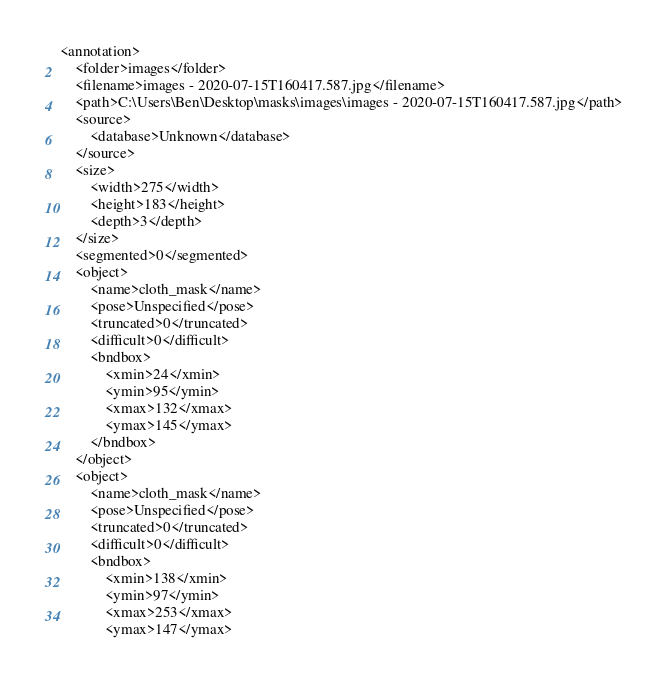<code> <loc_0><loc_0><loc_500><loc_500><_XML_><annotation>
	<folder>images</folder>
	<filename>images - 2020-07-15T160417.587.jpg</filename>
	<path>C:\Users\Ben\Desktop\masks\images\images - 2020-07-15T160417.587.jpg</path>
	<source>
		<database>Unknown</database>
	</source>
	<size>
		<width>275</width>
		<height>183</height>
		<depth>3</depth>
	</size>
	<segmented>0</segmented>
	<object>
		<name>cloth_mask</name>
		<pose>Unspecified</pose>
		<truncated>0</truncated>
		<difficult>0</difficult>
		<bndbox>
			<xmin>24</xmin>
			<ymin>95</ymin>
			<xmax>132</xmax>
			<ymax>145</ymax>
		</bndbox>
	</object>
	<object>
		<name>cloth_mask</name>
		<pose>Unspecified</pose>
		<truncated>0</truncated>
		<difficult>0</difficult>
		<bndbox>
			<xmin>138</xmin>
			<ymin>97</ymin>
			<xmax>253</xmax>
			<ymax>147</ymax></code> 